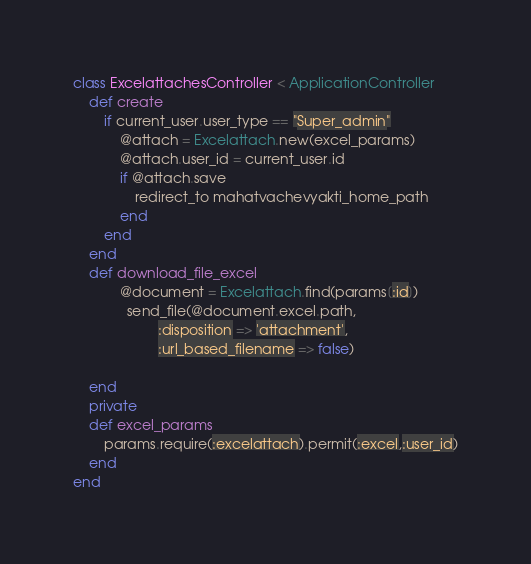<code> <loc_0><loc_0><loc_500><loc_500><_Ruby_>class ExcelattachesController < ApplicationController
	def create
		if current_user.user_type == "Super_admin"
			@attach = Excelattach.new(excel_params)
			@attach.user_id = current_user.id
			if @attach.save
				redirect_to mahatvachevyakti_home_path
			end
		end
	end
	def download_file_excel
		    @document = Excelattach.find(params[:id])
		      send_file(@document.excel.path,
		              :disposition => 'attachment',
		              :url_based_filename => false)
		     
	end
	private
	def excel_params
		params.require(:excelattach).permit(:excel,:user_id)
	end
end
</code> 